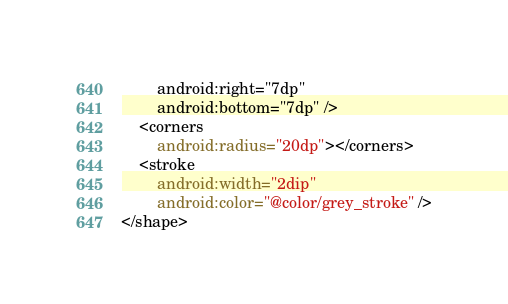Convert code to text. <code><loc_0><loc_0><loc_500><loc_500><_XML_>        android:right="7dp"
        android:bottom="7dp" />
    <corners
        android:radius="20dp"></corners>
    <stroke
        android:width="2dip"
        android:color="@color/grey_stroke" />
</shape>
</code> 